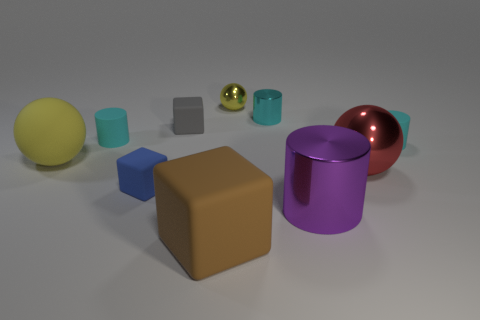There is a cyan matte object to the right of the tiny block in front of the tiny cyan matte thing that is left of the red object; what is its shape? The cyan matte object you're referring to is indeed shaped like a cylinder. It's positioned to the right of the small block, which in turn is located in front of another small, cyan matte object to the left of a red spherical object. 